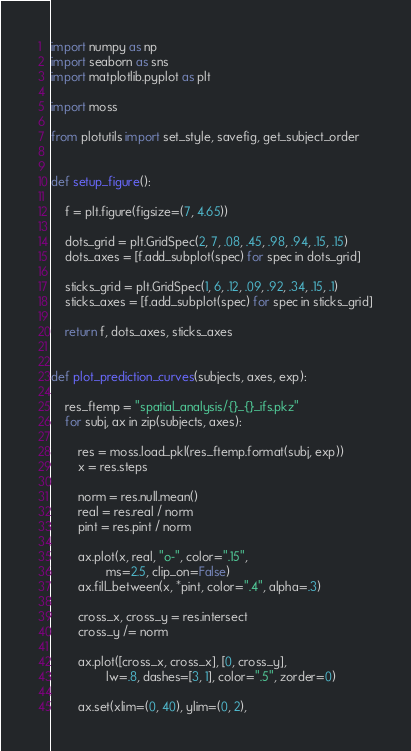<code> <loc_0><loc_0><loc_500><loc_500><_Python_>import numpy as np
import seaborn as sns
import matplotlib.pyplot as plt

import moss

from plotutils import set_style, savefig, get_subject_order


def setup_figure():

    f = plt.figure(figsize=(7, 4.65))

    dots_grid = plt.GridSpec(2, 7, .08, .45, .98, .94, .15, .15)
    dots_axes = [f.add_subplot(spec) for spec in dots_grid]

    sticks_grid = plt.GridSpec(1, 6, .12, .09, .92, .34, .15, .1)
    sticks_axes = [f.add_subplot(spec) for spec in sticks_grid]

    return f, dots_axes, sticks_axes


def plot_prediction_curves(subjects, axes, exp):

    res_ftemp = "spatial_analysis/{}_{}_ifs.pkz"
    for subj, ax in zip(subjects, axes):

        res = moss.load_pkl(res_ftemp.format(subj, exp))
        x = res.steps

        norm = res.null.mean()
        real = res.real / norm
        pint = res.pint / norm

        ax.plot(x, real, "o-", color=".15",
                ms=2.5, clip_on=False)
        ax.fill_between(x, *pint, color=".4", alpha=.3)

        cross_x, cross_y = res.intersect
        cross_y /= norm

        ax.plot([cross_x, cross_x], [0, cross_y],
                lw=.8, dashes=[3, 1], color=".5", zorder=0)

        ax.set(xlim=(0, 40), ylim=(0, 2),</code> 